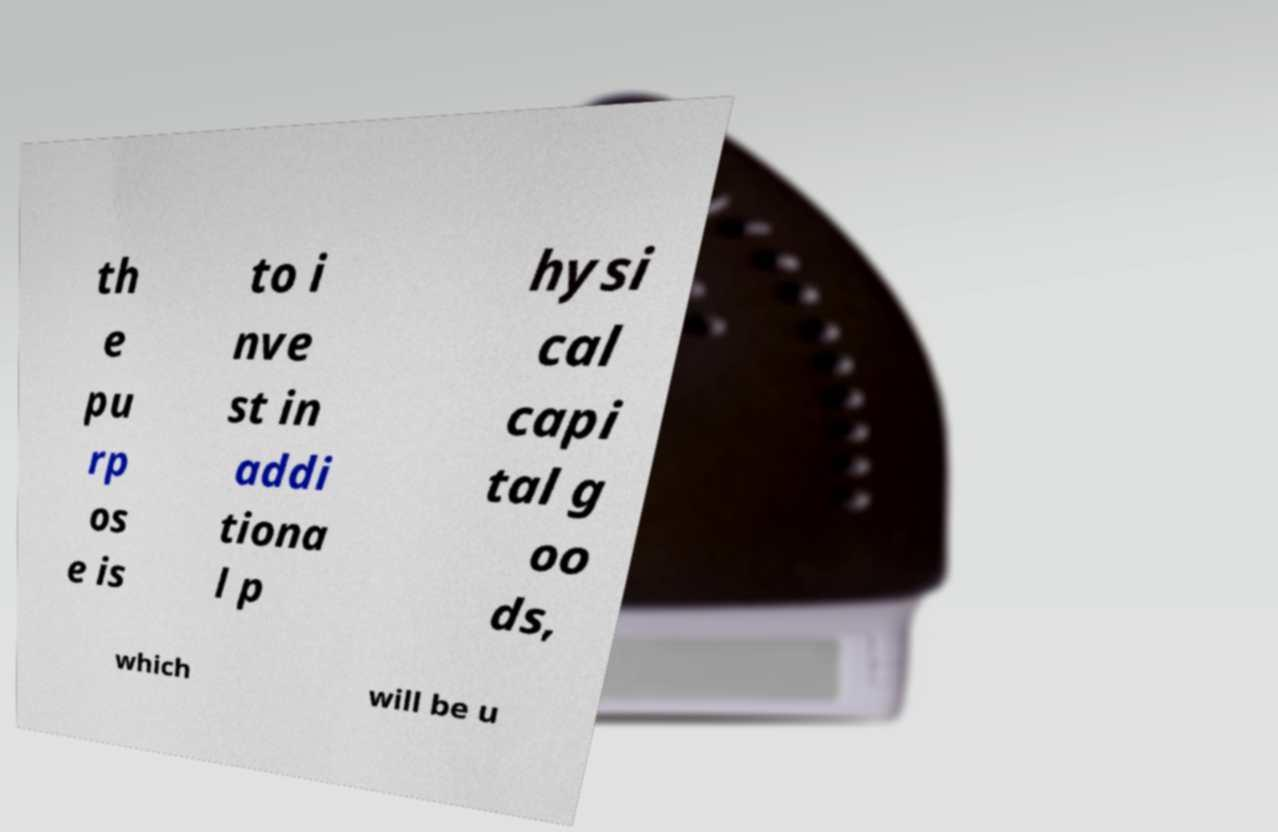I need the written content from this picture converted into text. Can you do that? th e pu rp os e is to i nve st in addi tiona l p hysi cal capi tal g oo ds, which will be u 